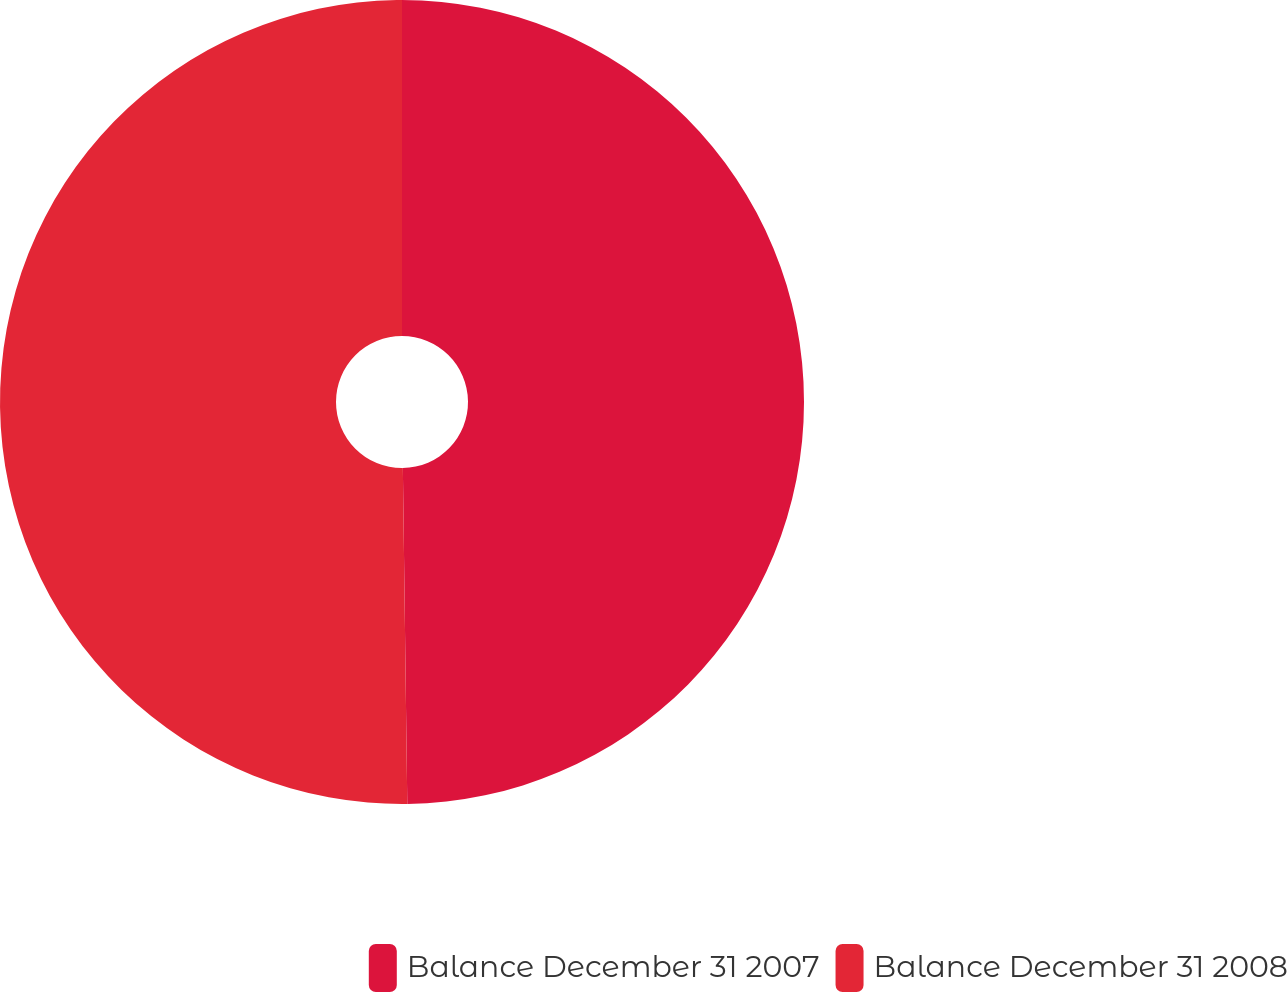<chart> <loc_0><loc_0><loc_500><loc_500><pie_chart><fcel>Balance December 31 2007<fcel>Balance December 31 2008<nl><fcel>49.79%<fcel>50.21%<nl></chart> 